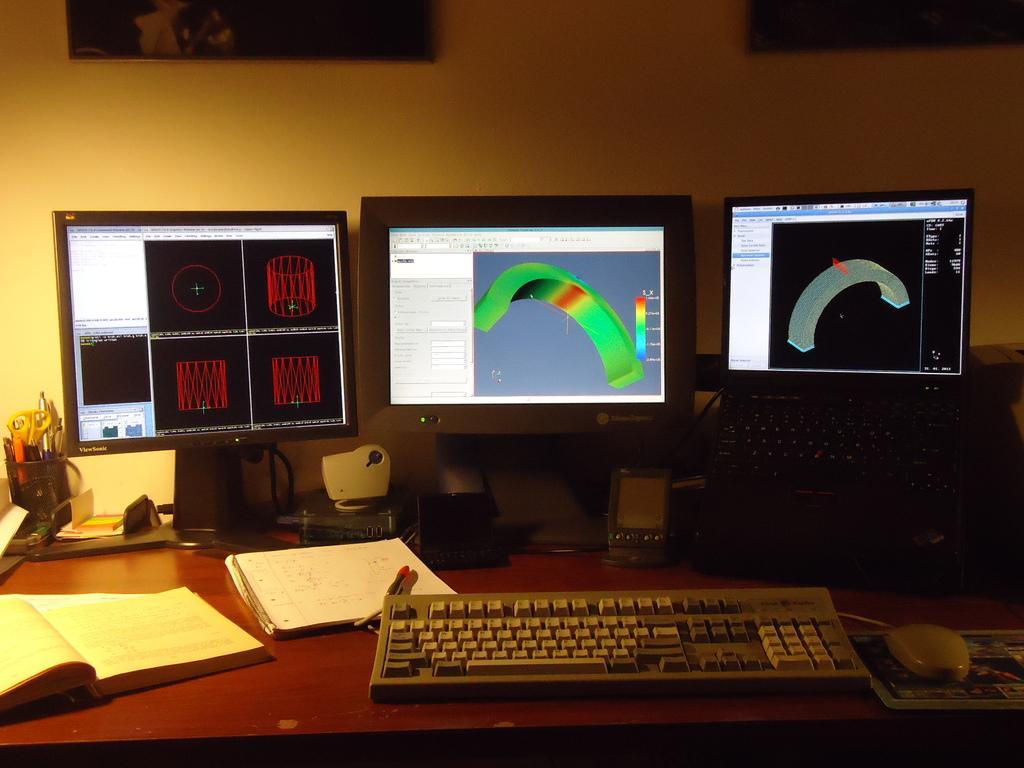Can you describe this image briefly? In this picture we have 3 computers , 1 key board , 1 mouse , 2 speakers , 1 pen stand , 2 books ,1 pen , at the wall we have 2 photo frames attached to it. 